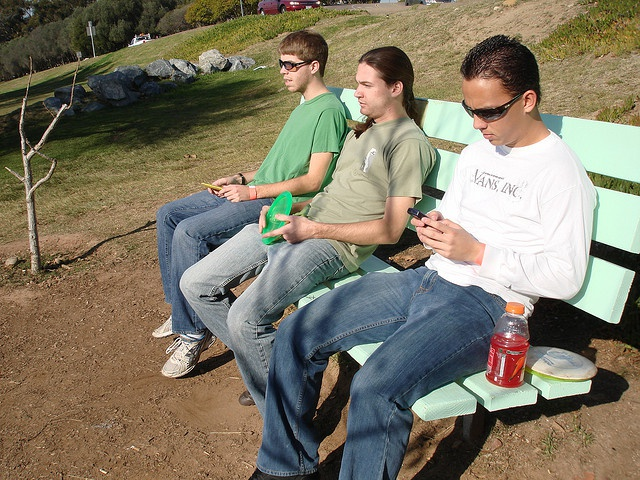Describe the objects in this image and their specific colors. I can see people in black, white, gray, and blue tones, people in black, darkgray, tan, and gray tones, bench in black, beige, and darkgray tones, people in black, lightgreen, and gray tones, and bottle in black, brown, gray, and darkgray tones in this image. 